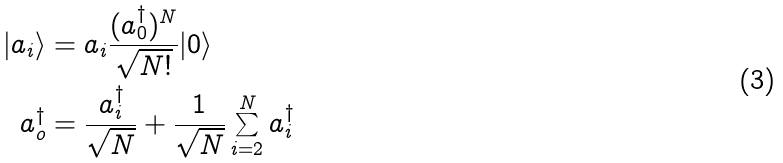Convert formula to latex. <formula><loc_0><loc_0><loc_500><loc_500>| a _ { i } \rangle & = a _ { i } \frac { ( a _ { 0 } ^ { \dagger } ) ^ { N } } { \sqrt { N ! } } | 0 \rangle \\ a _ { o } ^ { \dagger } & = \frac { a _ { i } ^ { \dagger } } { \sqrt { N } } + \frac { 1 } { \sqrt { N } } \sum _ { i = 2 } ^ { N } a _ { i } ^ { \dagger }</formula> 